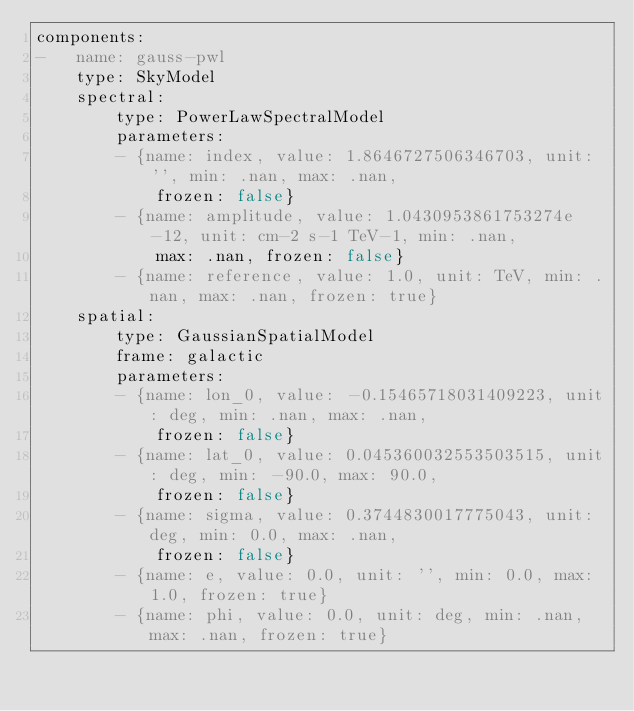Convert code to text. <code><loc_0><loc_0><loc_500><loc_500><_YAML_>components:
-   name: gauss-pwl
    type: SkyModel
    spectral:
        type: PowerLawSpectralModel
        parameters:
        - {name: index, value: 1.8646727506346703, unit: '', min: .nan, max: .nan,
            frozen: false}
        - {name: amplitude, value: 1.0430953861753274e-12, unit: cm-2 s-1 TeV-1, min: .nan,
            max: .nan, frozen: false}
        - {name: reference, value: 1.0, unit: TeV, min: .nan, max: .nan, frozen: true}
    spatial:
        type: GaussianSpatialModel
        frame: galactic
        parameters:
        - {name: lon_0, value: -0.15465718031409223, unit: deg, min: .nan, max: .nan,
            frozen: false}
        - {name: lat_0, value: 0.045360032553503515, unit: deg, min: -90.0, max: 90.0,
            frozen: false}
        - {name: sigma, value: 0.3744830017775043, unit: deg, min: 0.0, max: .nan,
            frozen: false}
        - {name: e, value: 0.0, unit: '', min: 0.0, max: 1.0, frozen: true}
        - {name: phi, value: 0.0, unit: deg, min: .nan, max: .nan, frozen: true}
</code> 